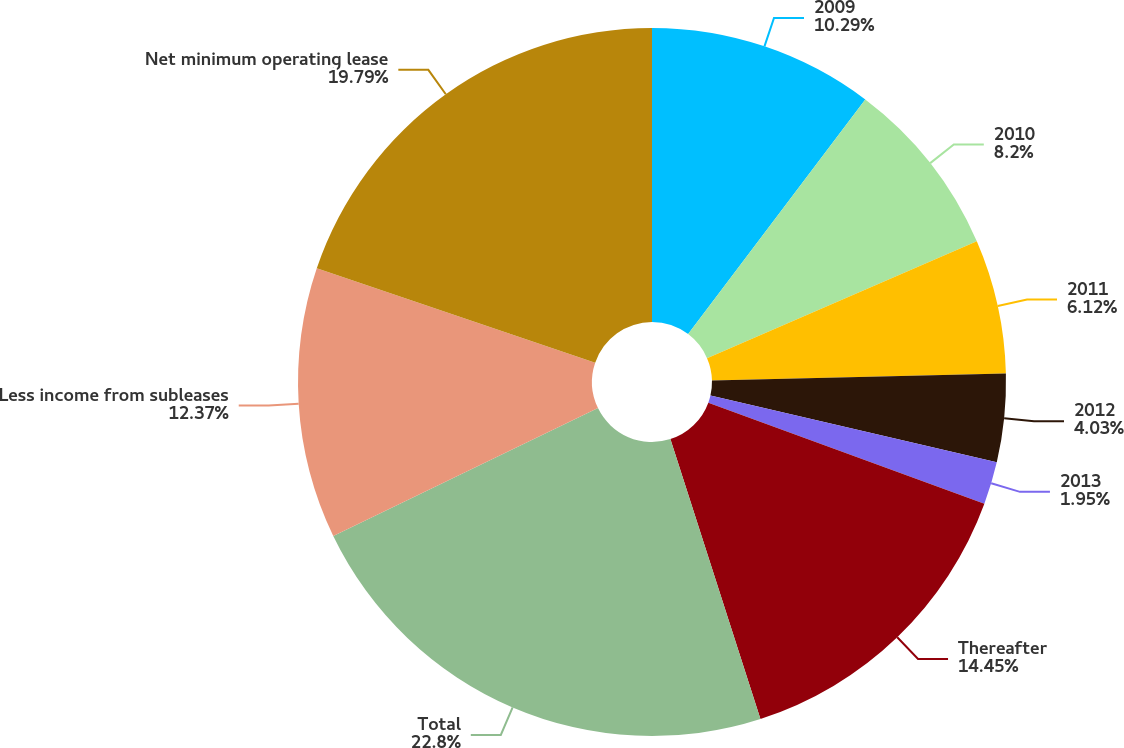Convert chart. <chart><loc_0><loc_0><loc_500><loc_500><pie_chart><fcel>2009<fcel>2010<fcel>2011<fcel>2012<fcel>2013<fcel>Thereafter<fcel>Total<fcel>Less income from subleases<fcel>Net minimum operating lease<nl><fcel>10.29%<fcel>8.2%<fcel>6.12%<fcel>4.03%<fcel>1.95%<fcel>14.45%<fcel>22.79%<fcel>12.37%<fcel>19.79%<nl></chart> 